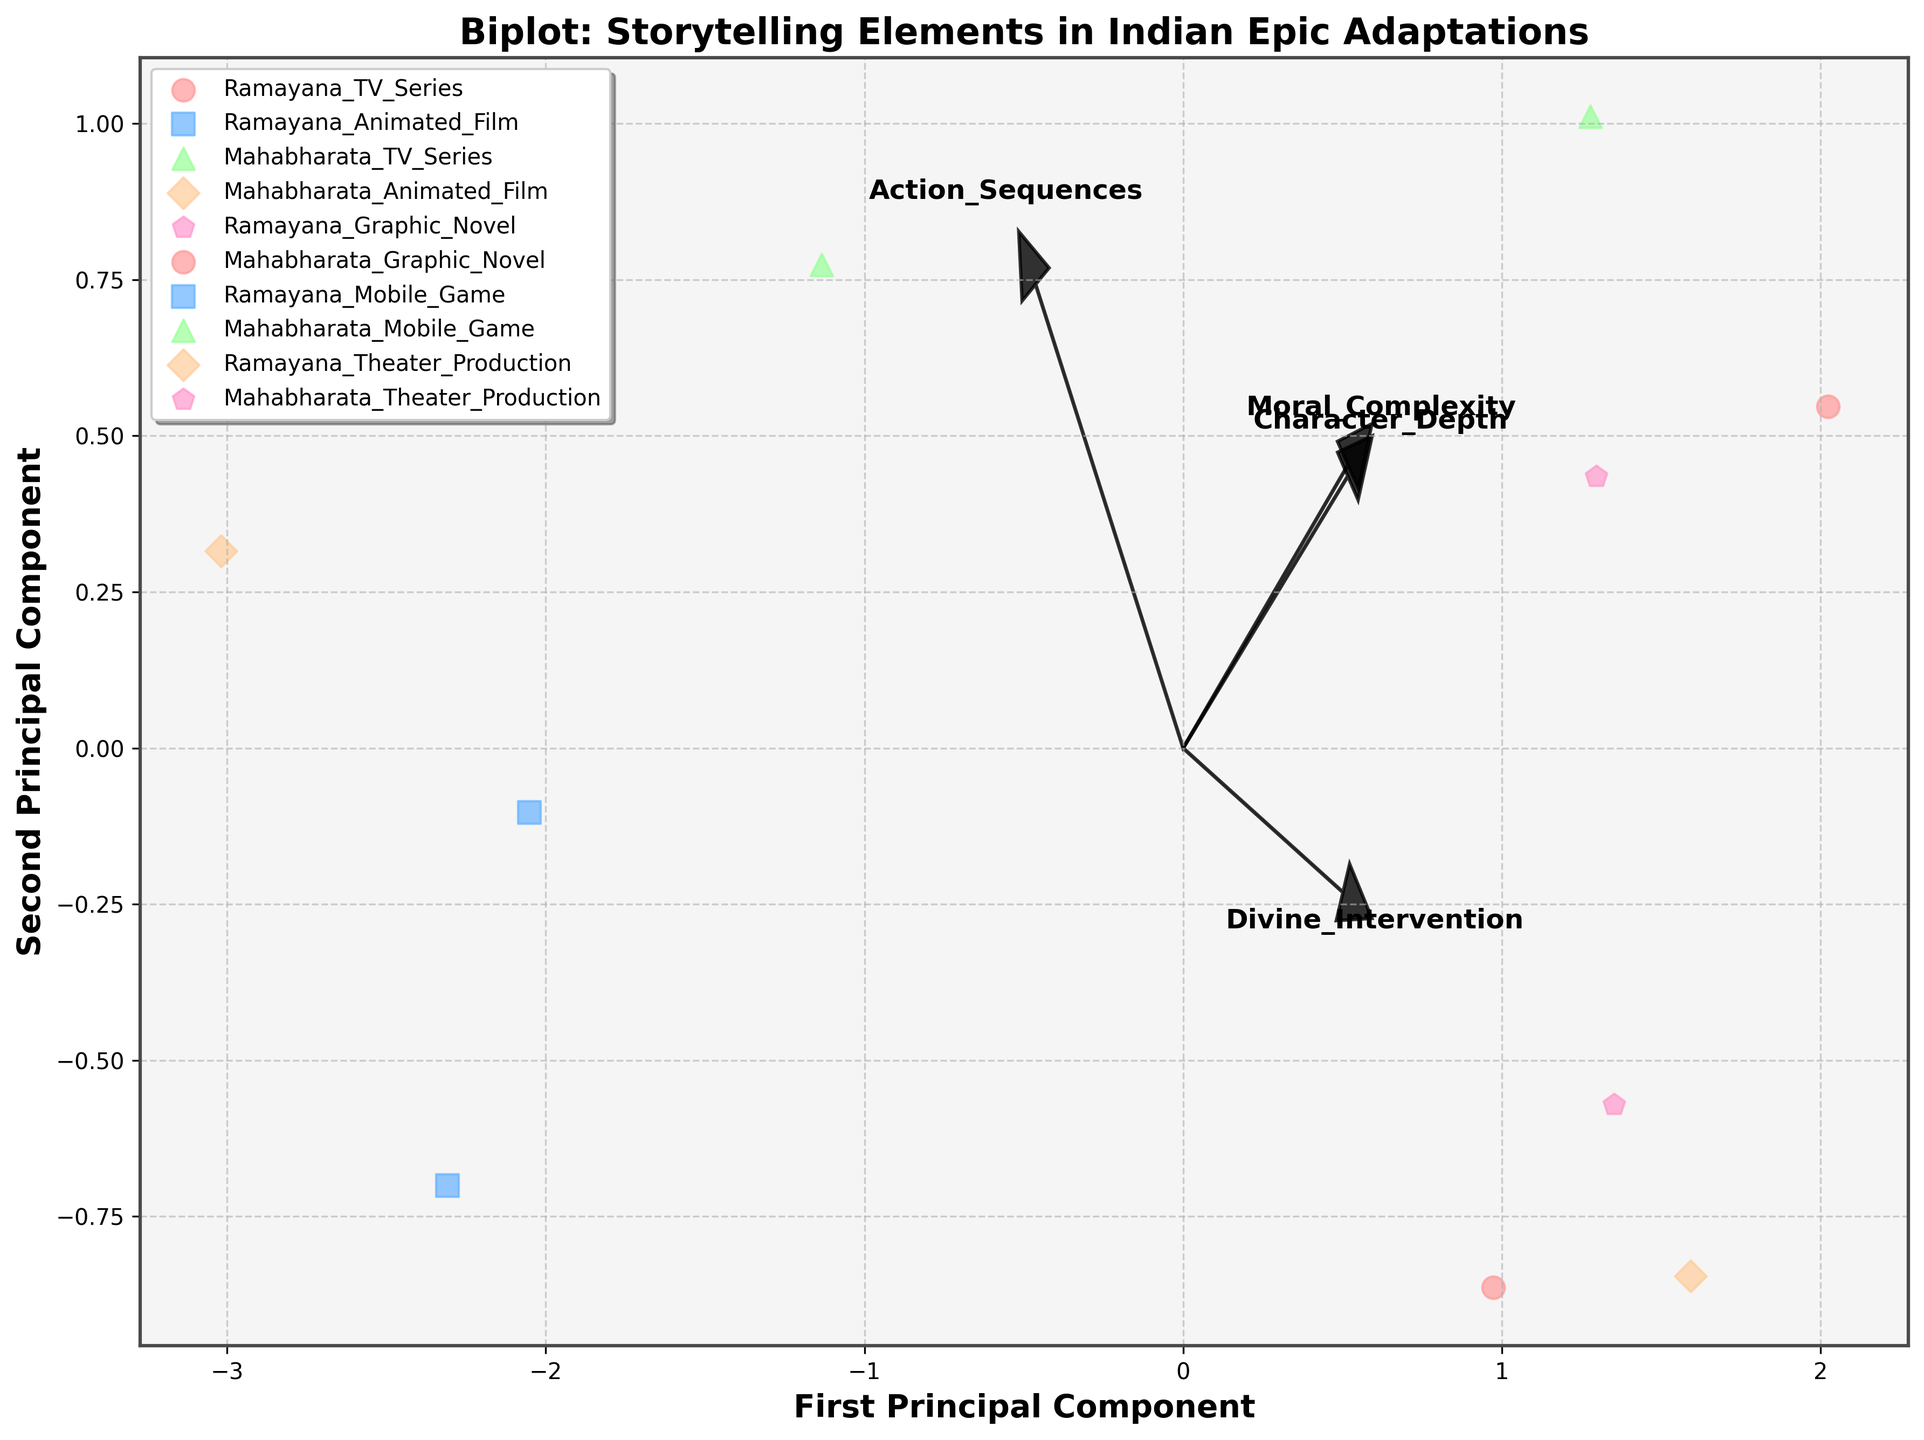Which adaptation format of Mahabharata has the highest Character Depth score? To determine which adaptation format of Mahabharata has the highest Character Depth score, look for the data points labeled as Mahabharata adaptations and compare their positions along the Character Depth axis. The Mahabharata Graphic Novel is seen having the highest Character Depth score.
Answer: Mahabharata Graphic Novel Which Ramayana adaptation type is closest to the Mahabharata TV Series in the biplot? Observe the Mahabharata TV Series point and identify the closest Ramayana adaptation in proximity within the biplot. The Ramayana Theater Production is closest to the Mahabharata TV Series in the biplot.
Answer: Ramayana Theater Production Between Ramayana Mobile Game and Ramayana Graphic Novel, which one has a higher Action Sequences score? Compare the relative positions of the Ramayana Mobile Game and Ramayana Graphic Novel points along the Action Sequences axis. The Ramayana Mobile Game has a higher Action Sequences score than the Ramayana Graphic Novel.
Answer: Ramayana Mobile Game What storytelling element has the largest influence on the first principal component in the biplot? Look at the feature vectors' direction and length within the biplot, noting the one that extends furthest in the direction of the first principal component axis. The Character Depth feature has the largest influence on the first principal component.
Answer: Character Depth Which adaptation possesses a balanced representation of Character Depth and Moral Complexity according to the biplot? To find an adaptation with balanced Character Depth and Moral Complexity, look for a point approximately equidistant along the vectors associated with these two features. The Mahabharata TV Series appears to have a balanced representation of Character Depth and Moral Complexity.
Answer: Mahabharata TV Series Compare the Divine Intervention scores between Mahabharata Graphic Novel and Ramayana Theater Production. Which one is higher? Observe the positions corresponding to Mahabharata Graphic Novel and Ramayana Theater Production along the Divine Intervention axis. The Mahabharata Graphic Novel has a higher Divine Intervention score compared to the Ramayana Theater Production.
Answer: Mahabharata Graphic Novel Which adaptation type primarily associated with Ramayana has the highest Moral Complexity score? Scan all Ramayana adaptation types and identify the one positioned highest along the Moral Complexity axis. The Ramayana Graphic Novel has the highest Moral Complexity score among Ramayana adaptations.
Answer: Ramayana Graphic Novel Is the variance in Moral Complexity greater for adaptations of Ramayana or Mahabharata? Examine and compare the spread of data points representing Moral Complexity scores for Ramayana and Mahabharata adaptations. The variance in Moral Complexity appears greater for Mahabharata adaptations.
Answer: Mahabharata Which adaptation type of Mahabharata is closer to having high Action Sequences and Divine Intervention, according to the biplot? Identify the Mahabharata adaptation point that is positioned close to both high Action Sequences and Divine Intervention vectors within the biplot. The Mahabharata Animated Film is positioned closer to having high Action Sequences and Divine Intervention.
Answer: Mahabharata Animated Film 